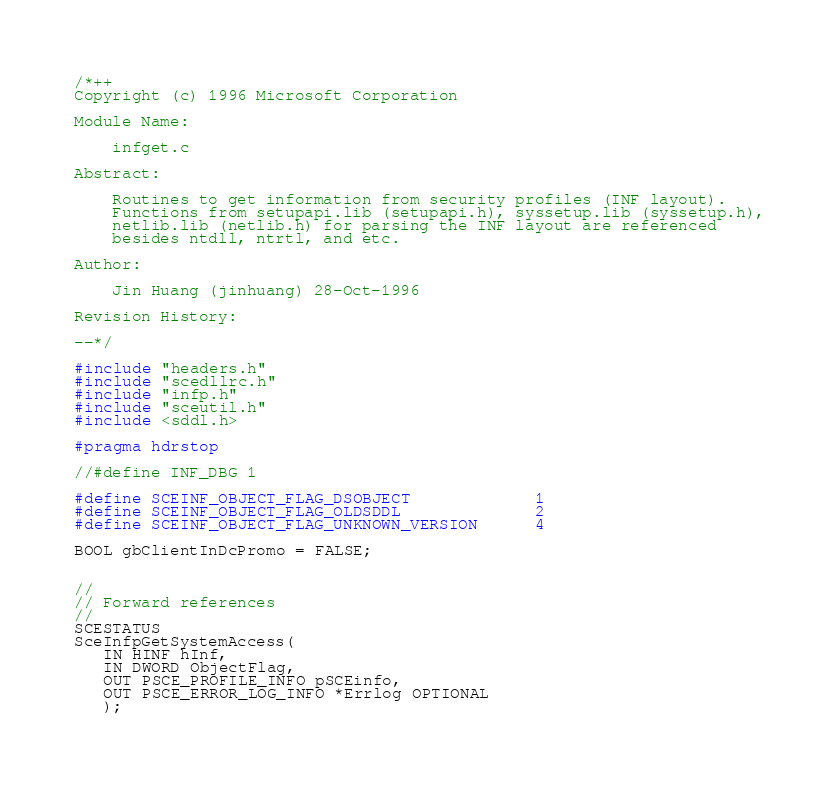<code> <loc_0><loc_0><loc_500><loc_500><_C++_>/*++
Copyright (c) 1996 Microsoft Corporation

Module Name:

    infget.c

Abstract:

    Routines to get information from security profiles (INF layout).
    Functions from setupapi.lib (setupapi.h), syssetup.lib (syssetup.h),
    netlib.lib (netlib.h) for parsing the INF layout are referenced
    besides ntdll, ntrtl, and etc.

Author:

    Jin Huang (jinhuang) 28-Oct-1996

Revision History:

--*/

#include "headers.h"
#include "scedllrc.h"
#include "infp.h"
#include "sceutil.h"
#include <sddl.h>

#pragma hdrstop

//#define INF_DBG 1

#define SCEINF_OBJECT_FLAG_DSOBJECT             1
#define SCEINF_OBJECT_FLAG_OLDSDDL              2
#define SCEINF_OBJECT_FLAG_UNKNOWN_VERSION      4

BOOL gbClientInDcPromo = FALSE;


//
// Forward references
//
SCESTATUS
SceInfpGetSystemAccess(
   IN HINF hInf,
   IN DWORD ObjectFlag,
   OUT PSCE_PROFILE_INFO pSCEinfo,
   OUT PSCE_ERROR_LOG_INFO *Errlog OPTIONAL
   );
</code> 